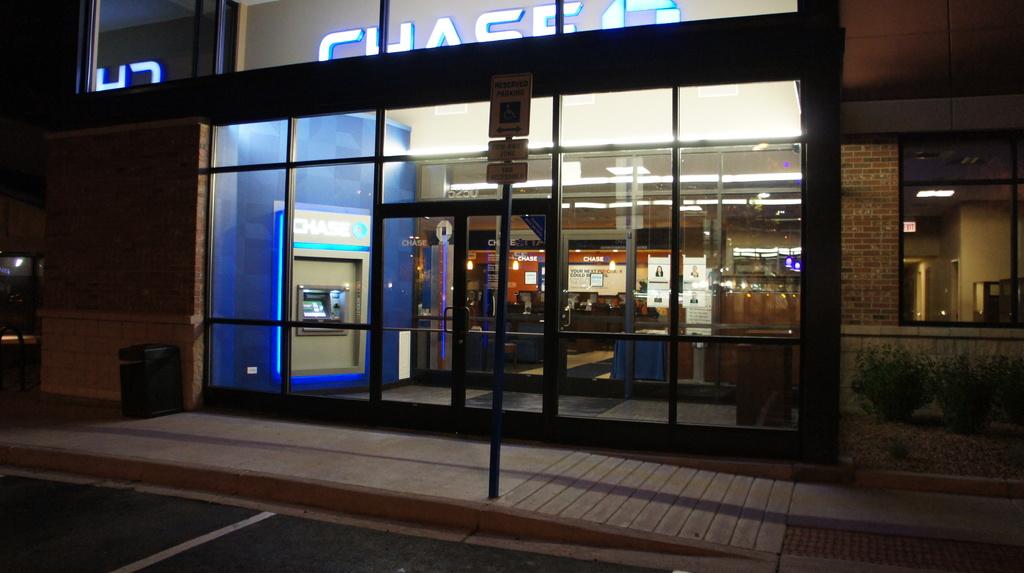What is the name above the atm machine?
Your answer should be very brief. Chase. What color letters is the brand name?
Make the answer very short. White. 